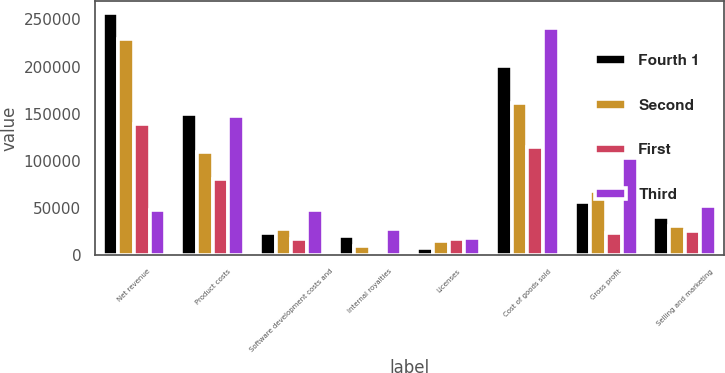Convert chart. <chart><loc_0><loc_0><loc_500><loc_500><stacked_bar_chart><ecel><fcel>Net revenue<fcel>Product costs<fcel>Software development costs and<fcel>Internal royalties<fcel>Licenses<fcel>Cost of goods sold<fcel>Gross profit<fcel>Selling and marketing<nl><fcel>Fourth 1<fcel>256810<fcel>149946<fcel>23302<fcel>20472<fcel>7182<fcel>200902<fcel>55908<fcel>40774<nl><fcel>Second<fcel>229722<fcel>108995<fcel>28012<fcel>9659<fcel>14936<fcel>161602<fcel>68120<fcel>31044<nl><fcel>First<fcel>138564<fcel>80550<fcel>17156<fcel>368<fcel>16835<fcel>114909<fcel>23655<fcel>25335<nl><fcel>Third<fcel>47490<fcel>147271<fcel>47490<fcel>27725<fcel>17927<fcel>240413<fcel>102979<fcel>51471<nl></chart> 